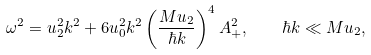Convert formula to latex. <formula><loc_0><loc_0><loc_500><loc_500>\omega ^ { 2 } = u _ { 2 } ^ { 2 } k ^ { 2 } + 6 u _ { 0 } ^ { 2 } k ^ { 2 } \left ( \frac { M u _ { 2 } } { \hbar { k } } \right ) ^ { 4 } A _ { + } ^ { 2 } , \quad \hbar { k } \ll M u _ { 2 } ,</formula> 